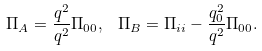Convert formula to latex. <formula><loc_0><loc_0><loc_500><loc_500>\Pi _ { A } = \frac { q ^ { 2 } } { q ^ { 2 } } \Pi _ { 0 0 } , \, \ \Pi _ { B } = \Pi _ { i i } - \frac { q _ { 0 } ^ { 2 } } { q ^ { 2 } } \Pi _ { 0 0 } .</formula> 